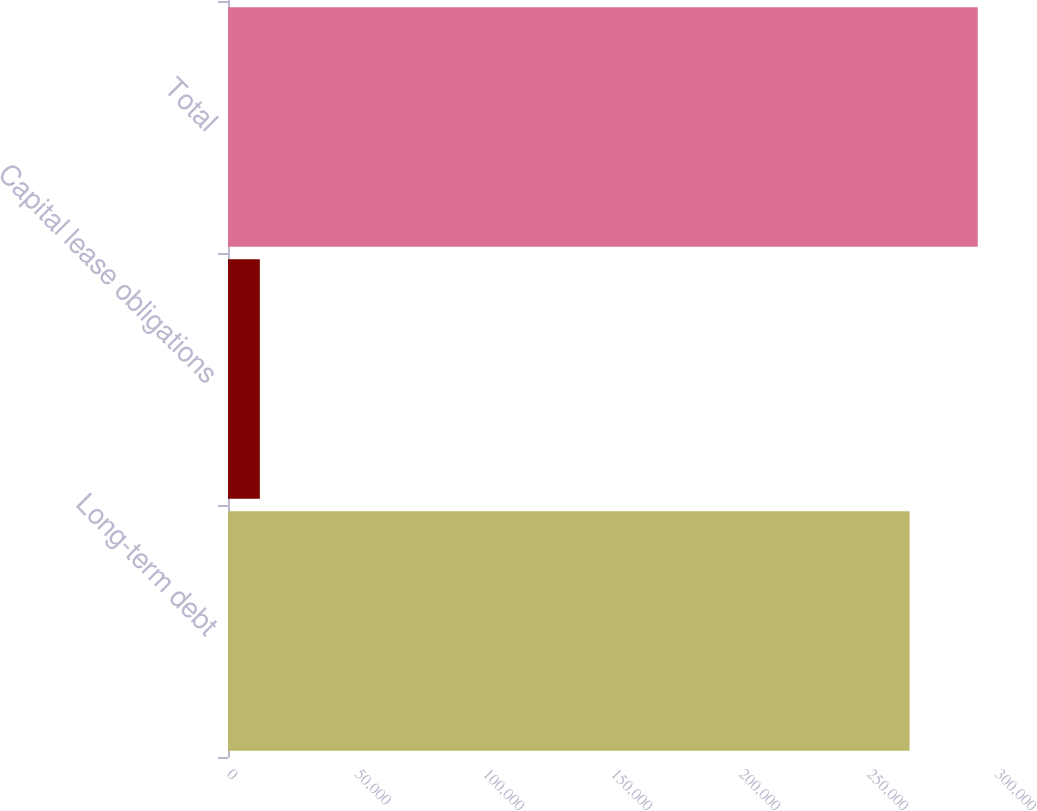Convert chart. <chart><loc_0><loc_0><loc_500><loc_500><bar_chart><fcel>Long-term debt<fcel>Capital lease obligations<fcel>Total<nl><fcel>266250<fcel>12436<fcel>292875<nl></chart> 